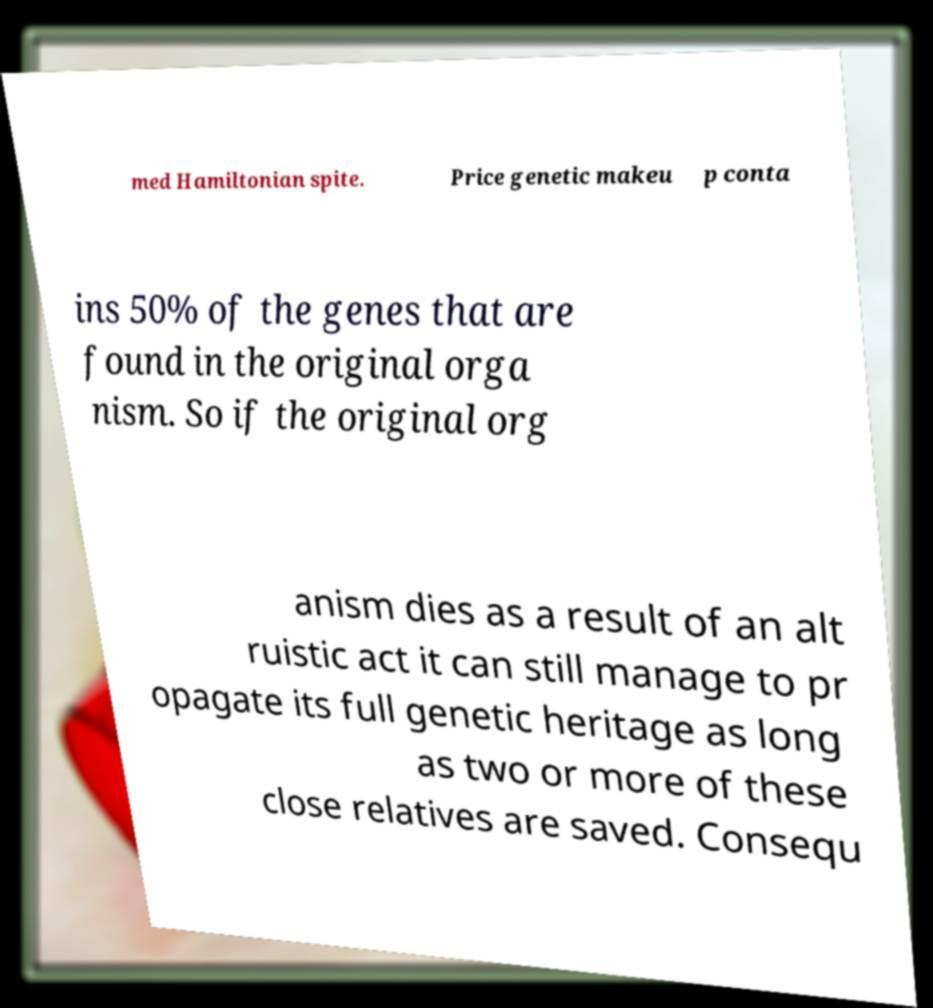What messages or text are displayed in this image? I need them in a readable, typed format. med Hamiltonian spite. Price genetic makeu p conta ins 50% of the genes that are found in the original orga nism. So if the original org anism dies as a result of an alt ruistic act it can still manage to pr opagate its full genetic heritage as long as two or more of these close relatives are saved. Consequ 